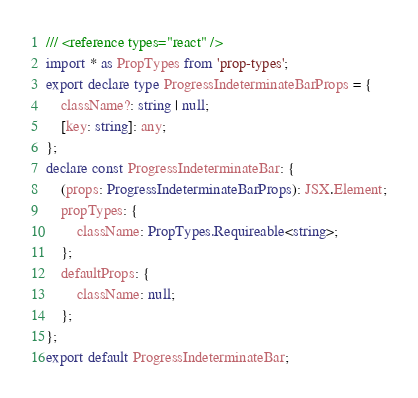Convert code to text. <code><loc_0><loc_0><loc_500><loc_500><_TypeScript_>/// <reference types="react" />
import * as PropTypes from 'prop-types';
export declare type ProgressIndeterminateBarProps = {
    className?: string | null;
    [key: string]: any;
};
declare const ProgressIndeterminateBar: {
    (props: ProgressIndeterminateBarProps): JSX.Element;
    propTypes: {
        className: PropTypes.Requireable<string>;
    };
    defaultProps: {
        className: null;
    };
};
export default ProgressIndeterminateBar;
</code> 